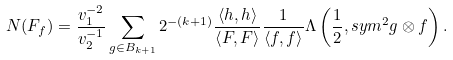<formula> <loc_0><loc_0><loc_500><loc_500>N ( F _ { f } ) = \frac { v _ { 1 } ^ { - 2 } } { v _ { 2 } ^ { - 1 } } \sum _ { g \in B _ { k + 1 } } 2 ^ { - ( k + 1 ) } \frac { \left \langle h , h \right \rangle } { \left \langle F , F \right \rangle } \frac { 1 } { \left \langle f , f \right \rangle } \Lambda \left ( \frac { 1 } { 2 } , s y m ^ { 2 } g \otimes f \right ) .</formula> 